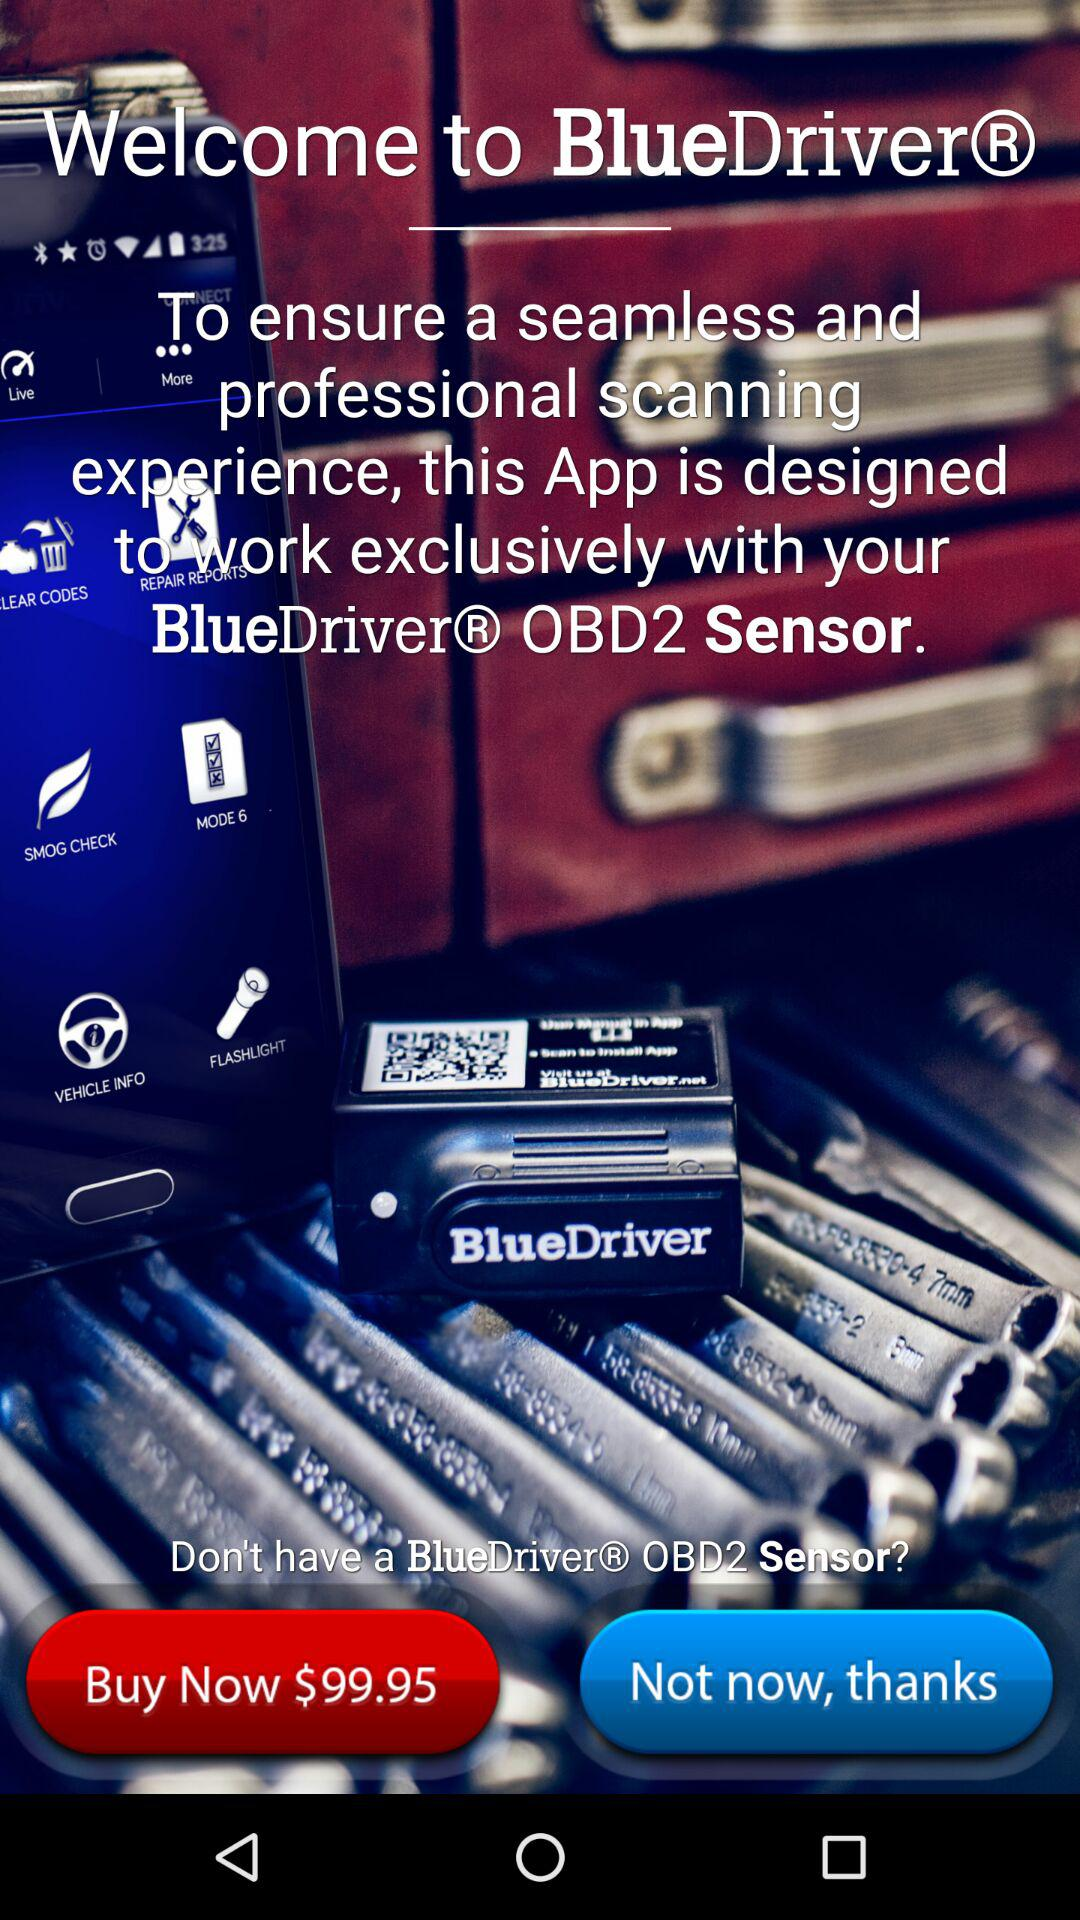Which version of "BlueDriver" is this?
When the provided information is insufficient, respond with <no answer>. <no answer> 